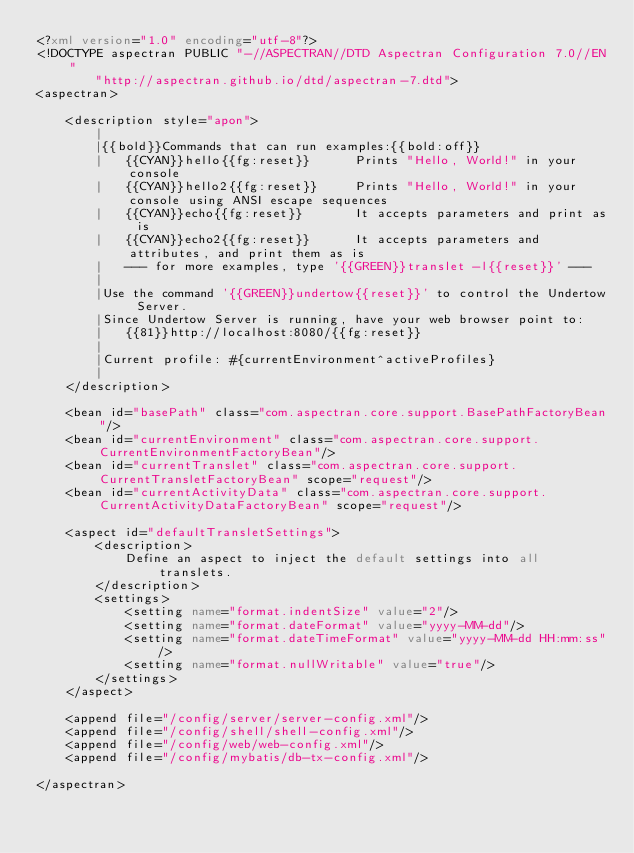Convert code to text. <code><loc_0><loc_0><loc_500><loc_500><_XML_><?xml version="1.0" encoding="utf-8"?>
<!DOCTYPE aspectran PUBLIC "-//ASPECTRAN//DTD Aspectran Configuration 7.0//EN"
        "http://aspectran.github.io/dtd/aspectran-7.dtd">
<aspectran>

    <description style="apon">
        |
        |{{bold}}Commands that can run examples:{{bold:off}}
        |   {{CYAN}}hello{{fg:reset}}      Prints "Hello, World!" in your console
        |   {{CYAN}}hello2{{fg:reset}}     Prints "Hello, World!" in your console using ANSI escape sequences
        |   {{CYAN}}echo{{fg:reset}}       It accepts parameters and print as is
        |   {{CYAN}}echo2{{fg:reset}}      It accepts parameters and attributes, and print them as is
        |   --- for more examples, type '{{GREEN}}translet -l{{reset}}' ---
        |
        |Use the command '{{GREEN}}undertow{{reset}}' to control the Undertow Server.
        |Since Undertow Server is running, have your web browser point to:
        |   {{81}}http://localhost:8080/{{fg:reset}}
        |
        |Current profile: #{currentEnvironment^activeProfiles}
        |
    </description>

    <bean id="basePath" class="com.aspectran.core.support.BasePathFactoryBean"/>
    <bean id="currentEnvironment" class="com.aspectran.core.support.CurrentEnvironmentFactoryBean"/>
    <bean id="currentTranslet" class="com.aspectran.core.support.CurrentTransletFactoryBean" scope="request"/>
    <bean id="currentActivityData" class="com.aspectran.core.support.CurrentActivityDataFactoryBean" scope="request"/>

    <aspect id="defaultTransletSettings">
        <description>
            Define an aspect to inject the default settings into all translets.
        </description>
        <settings>
            <setting name="format.indentSize" value="2"/>
            <setting name="format.dateFormat" value="yyyy-MM-dd"/>
            <setting name="format.dateTimeFormat" value="yyyy-MM-dd HH:mm:ss"/>
            <setting name="format.nullWritable" value="true"/>
        </settings>
    </aspect>

    <append file="/config/server/server-config.xml"/>
    <append file="/config/shell/shell-config.xml"/>
    <append file="/config/web/web-config.xml"/>
    <append file="/config/mybatis/db-tx-config.xml"/>

</aspectran></code> 